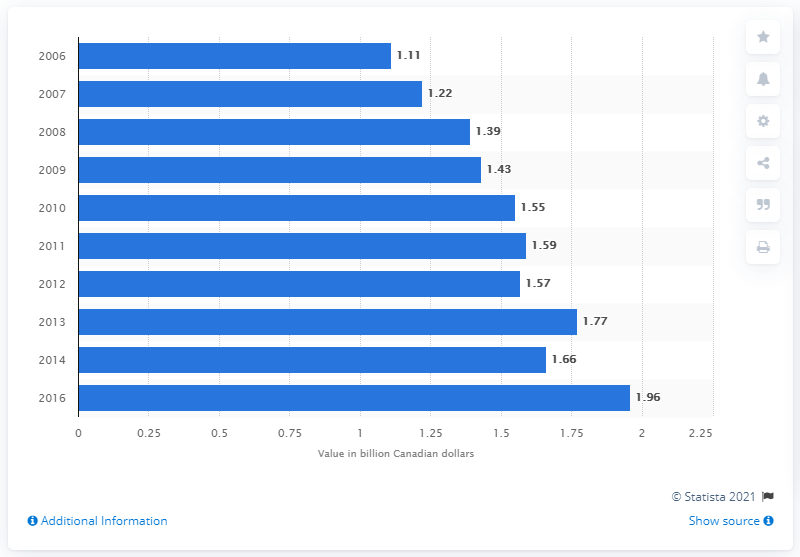Specify some key components in this picture. In 2016, the sponsorship industry in Canada was valued at CAD 1.96 billion. In 2014, the sponsorship industry was valued at approximately 1.66 billion dollars. 